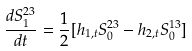<formula> <loc_0><loc_0><loc_500><loc_500>\frac { d S _ { 1 } ^ { 2 3 } } { d t } = \frac { 1 } { 2 } [ h _ { 1 , t } S _ { 0 } ^ { 2 3 } - h _ { 2 , t } S _ { 0 } ^ { 1 3 } ]</formula> 